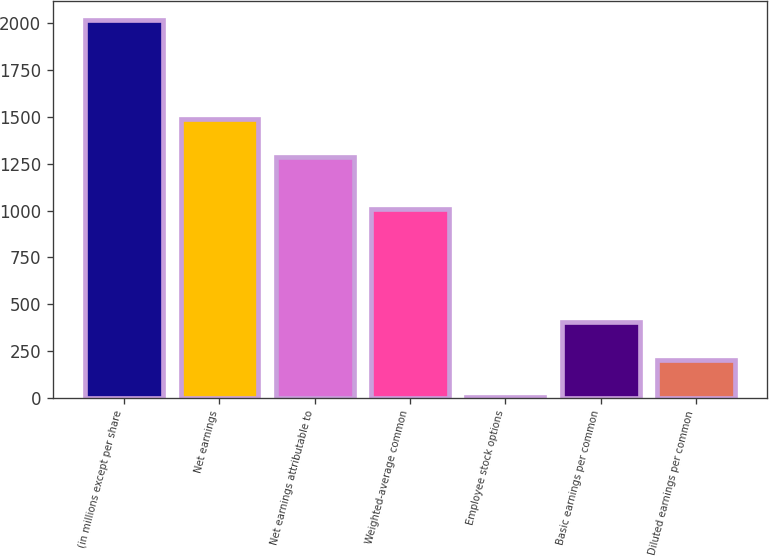Convert chart to OTSL. <chart><loc_0><loc_0><loc_500><loc_500><bar_chart><fcel>(in millions except per share<fcel>Net earnings<fcel>Net earnings attributable to<fcel>Weighted-average common<fcel>Employee stock options<fcel>Basic earnings per common<fcel>Diluted earnings per common<nl><fcel>2017<fcel>1489.4<fcel>1288<fcel>1010<fcel>3<fcel>405.8<fcel>204.4<nl></chart> 